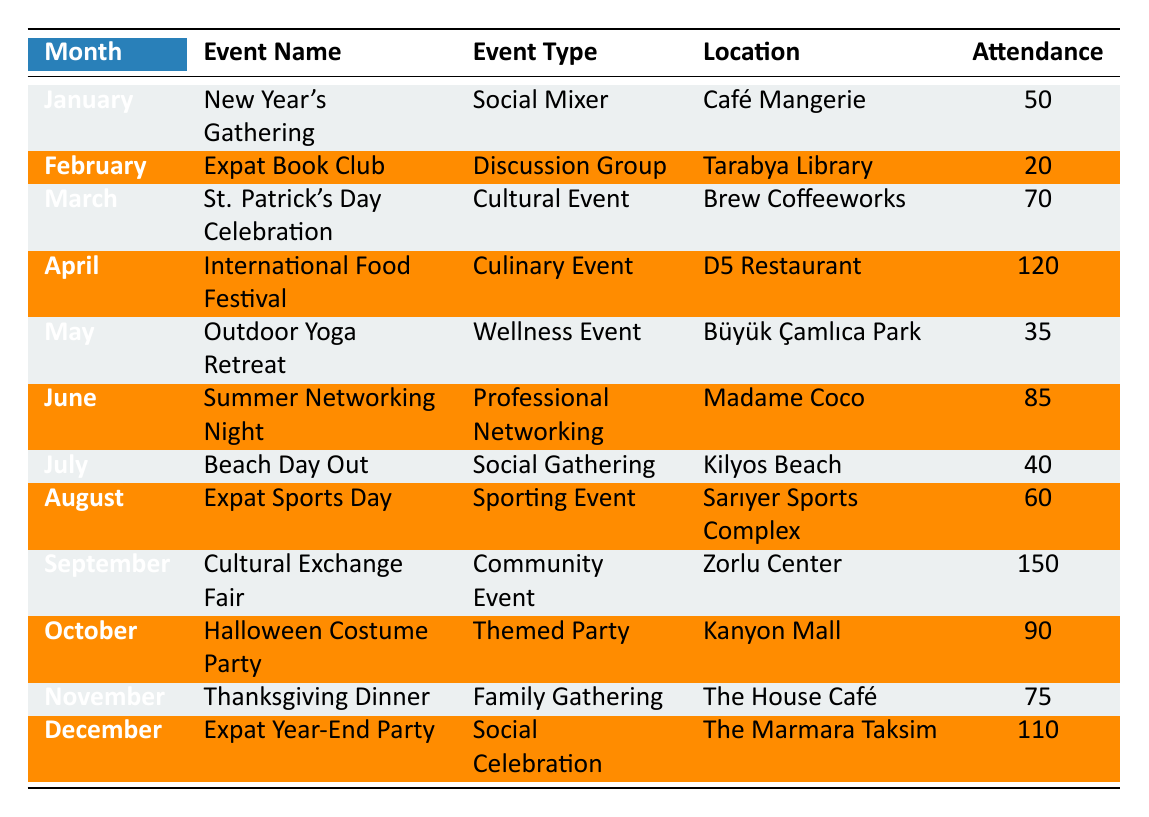What is the attendance at the International Food Festival in April? The table specifies that the International Food Festival was held in April and had an attendance of 120.
Answer: 120 Which month had the highest attendance, and what was the event? By comparing the attendance figures for each event listed in the table, September had the highest attendance of 150 at the Cultural Exchange Fair.
Answer: September, 150, Cultural Exchange Fair How many total attendees were there across all the events for the year? To find the total attendance, we sum all individual attendance figures: 50 + 20 + 70 + 120 + 35 + 85 + 40 + 60 + 150 + 90 + 75 + 110 = 1030.
Answer: 1030 Is there a holiday-themed event in November? The table indicates that November features the Thanksgiving Dinner, which is a holiday-themed event.
Answer: Yes What is the average attendance for the events that took place during the summer months (June, July, August)? The summer months are June, July, and August, with respective attendances of 85, 40, and 60. The average is calculated as (85 + 40 + 60) / 3 = 185 / 3 = 61.67.
Answer: 61.67 Which event had the lowest attendance, and how many people attended? Looking through the attendance figures in the table reveals that the Expat Book Club in February had the lowest attendance at 20.
Answer: February, 20 How many cultural events took place in the first half of the year (up to June)? The cultural events in the first half of the year are the New Year's Gathering in January, and the St. Patrick's Day Celebration in March. Thus, there are two cultural events.
Answer: 2 Which month had social gatherings, and what are the names of the events? The months with social gatherings are January (New Year's Gathering), July (Beach Day Out), and December (Expat Year-End Party).
Answer: January, July, December Was there any event held in August, and if so, what kind of event was it? Yes, there was an event in August called the Expat Sports Day, which is categorized as a sporting event.
Answer: Yes, Expat Sports Day, Sporting Event How much greater was the attendance at the Cultural Exchange Fair in September compared to the Outdoor Yoga Retreat in May? The attendance at the Cultural Exchange Fair in September is 150, while the attendance at the Outdoor Yoga Retreat in May is 35. The difference is 150 - 35 = 115.
Answer: 115 